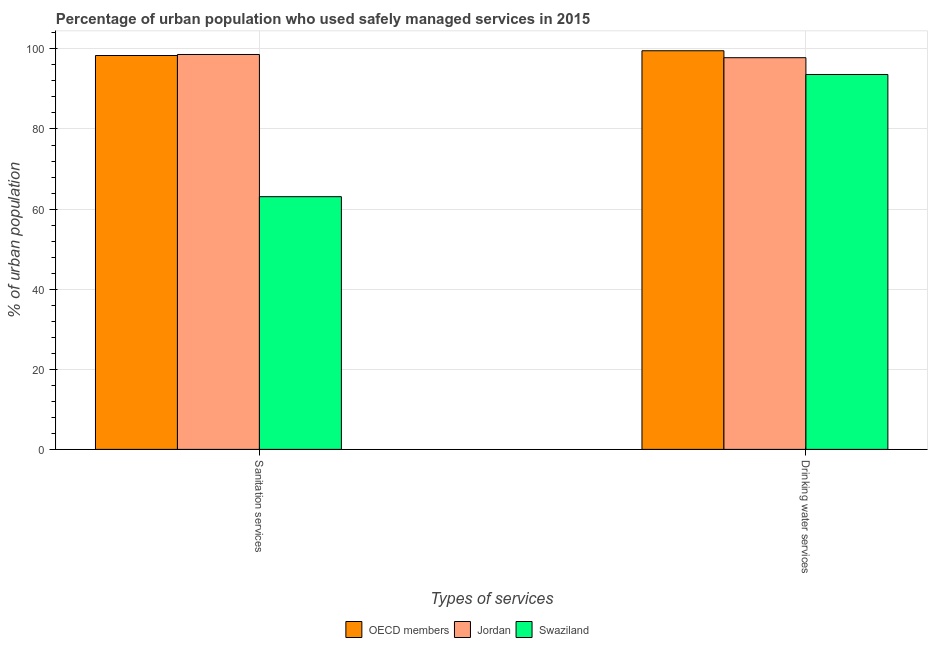How many different coloured bars are there?
Keep it short and to the point. 3. How many groups of bars are there?
Keep it short and to the point. 2. Are the number of bars on each tick of the X-axis equal?
Offer a very short reply. Yes. How many bars are there on the 2nd tick from the left?
Provide a succinct answer. 3. What is the label of the 2nd group of bars from the left?
Keep it short and to the point. Drinking water services. What is the percentage of urban population who used drinking water services in Jordan?
Offer a very short reply. 97.8. Across all countries, what is the maximum percentage of urban population who used sanitation services?
Your answer should be compact. 98.6. Across all countries, what is the minimum percentage of urban population who used drinking water services?
Offer a very short reply. 93.6. In which country was the percentage of urban population who used sanitation services minimum?
Offer a very short reply. Swaziland. What is the total percentage of urban population who used drinking water services in the graph?
Your answer should be very brief. 290.93. What is the difference between the percentage of urban population who used sanitation services in Swaziland and that in Jordan?
Make the answer very short. -35.5. What is the difference between the percentage of urban population who used sanitation services in Swaziland and the percentage of urban population who used drinking water services in Jordan?
Offer a terse response. -34.7. What is the average percentage of urban population who used drinking water services per country?
Ensure brevity in your answer.  96.98. What is the difference between the percentage of urban population who used drinking water services and percentage of urban population who used sanitation services in Jordan?
Offer a terse response. -0.8. What is the ratio of the percentage of urban population who used drinking water services in Swaziland to that in OECD members?
Make the answer very short. 0.94. What does the 3rd bar from the left in Drinking water services represents?
Your response must be concise. Swaziland. What does the 1st bar from the right in Drinking water services represents?
Your answer should be very brief. Swaziland. How many bars are there?
Offer a very short reply. 6. Are all the bars in the graph horizontal?
Your answer should be very brief. No. Does the graph contain any zero values?
Keep it short and to the point. No. What is the title of the graph?
Offer a very short reply. Percentage of urban population who used safely managed services in 2015. What is the label or title of the X-axis?
Your response must be concise. Types of services. What is the label or title of the Y-axis?
Your answer should be very brief. % of urban population. What is the % of urban population of OECD members in Sanitation services?
Your response must be concise. 98.35. What is the % of urban population in Jordan in Sanitation services?
Your answer should be very brief. 98.6. What is the % of urban population in Swaziland in Sanitation services?
Provide a succinct answer. 63.1. What is the % of urban population of OECD members in Drinking water services?
Provide a short and direct response. 99.53. What is the % of urban population in Jordan in Drinking water services?
Ensure brevity in your answer.  97.8. What is the % of urban population in Swaziland in Drinking water services?
Ensure brevity in your answer.  93.6. Across all Types of services, what is the maximum % of urban population in OECD members?
Your answer should be very brief. 99.53. Across all Types of services, what is the maximum % of urban population of Jordan?
Give a very brief answer. 98.6. Across all Types of services, what is the maximum % of urban population in Swaziland?
Provide a succinct answer. 93.6. Across all Types of services, what is the minimum % of urban population in OECD members?
Your response must be concise. 98.35. Across all Types of services, what is the minimum % of urban population of Jordan?
Keep it short and to the point. 97.8. Across all Types of services, what is the minimum % of urban population in Swaziland?
Your response must be concise. 63.1. What is the total % of urban population of OECD members in the graph?
Provide a short and direct response. 197.88. What is the total % of urban population in Jordan in the graph?
Provide a succinct answer. 196.4. What is the total % of urban population in Swaziland in the graph?
Provide a short and direct response. 156.7. What is the difference between the % of urban population of OECD members in Sanitation services and that in Drinking water services?
Keep it short and to the point. -1.19. What is the difference between the % of urban population of Swaziland in Sanitation services and that in Drinking water services?
Your response must be concise. -30.5. What is the difference between the % of urban population of OECD members in Sanitation services and the % of urban population of Jordan in Drinking water services?
Ensure brevity in your answer.  0.55. What is the difference between the % of urban population of OECD members in Sanitation services and the % of urban population of Swaziland in Drinking water services?
Provide a succinct answer. 4.75. What is the average % of urban population of OECD members per Types of services?
Keep it short and to the point. 98.94. What is the average % of urban population in Jordan per Types of services?
Make the answer very short. 98.2. What is the average % of urban population in Swaziland per Types of services?
Give a very brief answer. 78.35. What is the difference between the % of urban population of OECD members and % of urban population of Jordan in Sanitation services?
Ensure brevity in your answer.  -0.25. What is the difference between the % of urban population in OECD members and % of urban population in Swaziland in Sanitation services?
Provide a succinct answer. 35.25. What is the difference between the % of urban population of Jordan and % of urban population of Swaziland in Sanitation services?
Ensure brevity in your answer.  35.5. What is the difference between the % of urban population in OECD members and % of urban population in Jordan in Drinking water services?
Make the answer very short. 1.73. What is the difference between the % of urban population in OECD members and % of urban population in Swaziland in Drinking water services?
Make the answer very short. 5.93. What is the ratio of the % of urban population of Jordan in Sanitation services to that in Drinking water services?
Your answer should be compact. 1.01. What is the ratio of the % of urban population in Swaziland in Sanitation services to that in Drinking water services?
Your response must be concise. 0.67. What is the difference between the highest and the second highest % of urban population of OECD members?
Give a very brief answer. 1.19. What is the difference between the highest and the second highest % of urban population of Swaziland?
Provide a short and direct response. 30.5. What is the difference between the highest and the lowest % of urban population in OECD members?
Your answer should be compact. 1.19. What is the difference between the highest and the lowest % of urban population of Jordan?
Your answer should be compact. 0.8. What is the difference between the highest and the lowest % of urban population in Swaziland?
Provide a succinct answer. 30.5. 